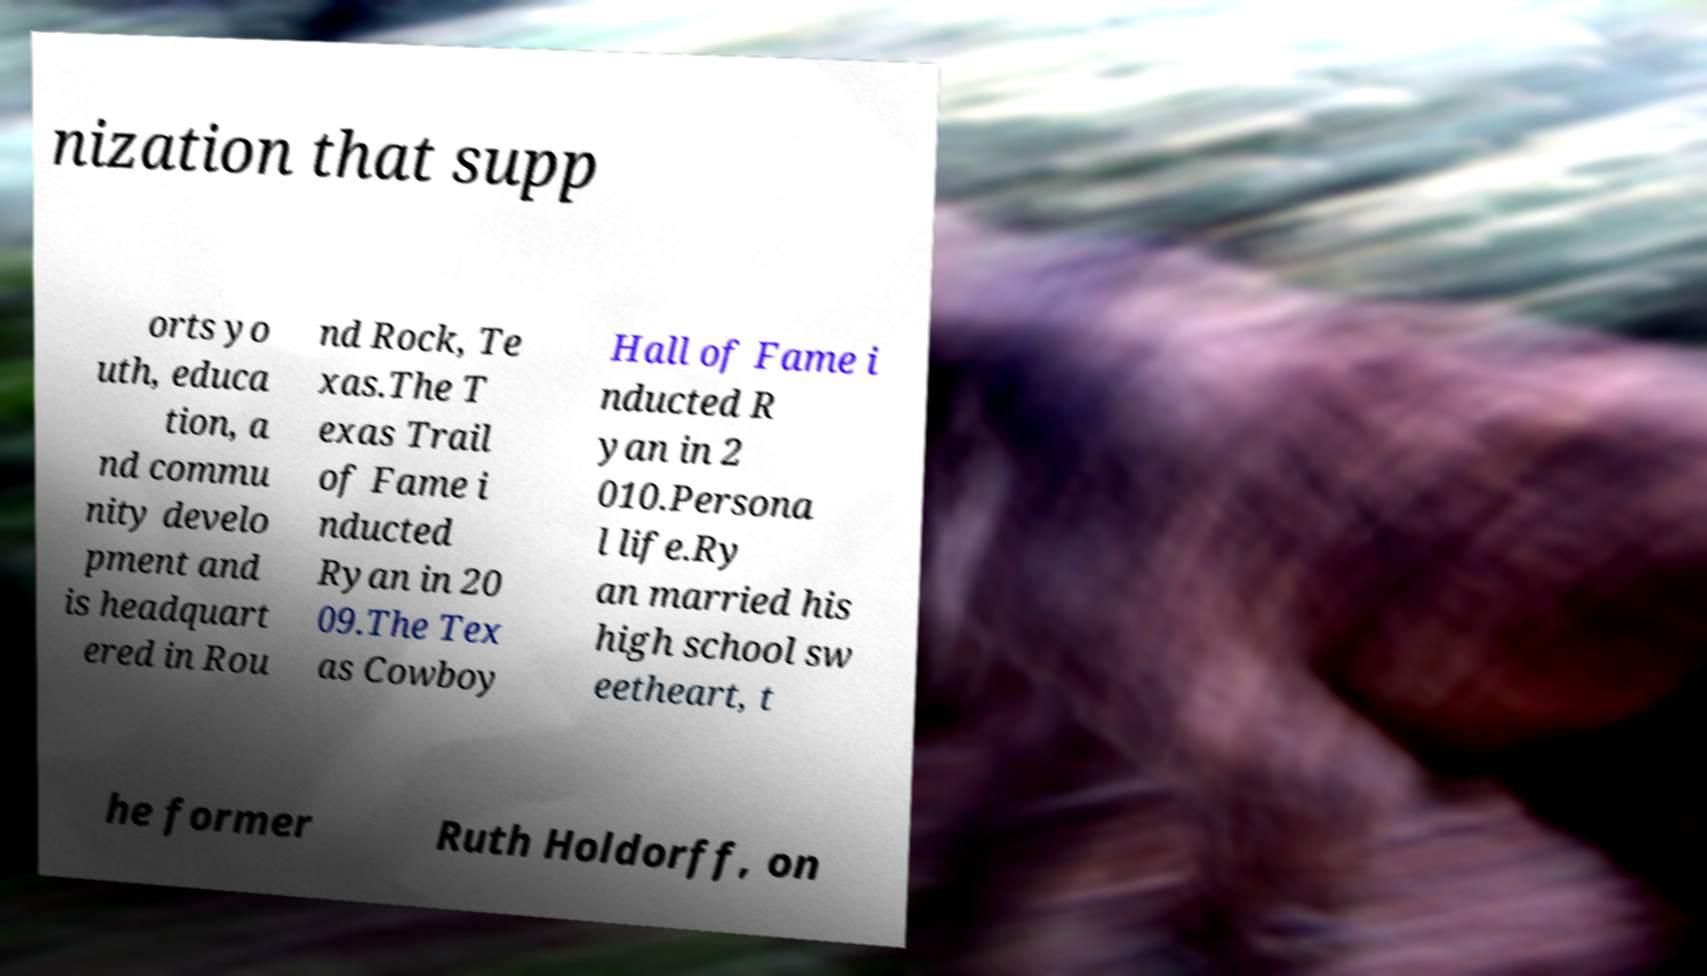Could you extract and type out the text from this image? nization that supp orts yo uth, educa tion, a nd commu nity develo pment and is headquart ered in Rou nd Rock, Te xas.The T exas Trail of Fame i nducted Ryan in 20 09.The Tex as Cowboy Hall of Fame i nducted R yan in 2 010.Persona l life.Ry an married his high school sw eetheart, t he former Ruth Holdorff, on 